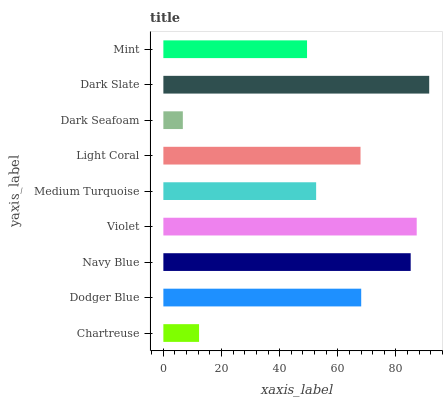Is Dark Seafoam the minimum?
Answer yes or no. Yes. Is Dark Slate the maximum?
Answer yes or no. Yes. Is Dodger Blue the minimum?
Answer yes or no. No. Is Dodger Blue the maximum?
Answer yes or no. No. Is Dodger Blue greater than Chartreuse?
Answer yes or no. Yes. Is Chartreuse less than Dodger Blue?
Answer yes or no. Yes. Is Chartreuse greater than Dodger Blue?
Answer yes or no. No. Is Dodger Blue less than Chartreuse?
Answer yes or no. No. Is Light Coral the high median?
Answer yes or no. Yes. Is Light Coral the low median?
Answer yes or no. Yes. Is Mint the high median?
Answer yes or no. No. Is Dodger Blue the low median?
Answer yes or no. No. 